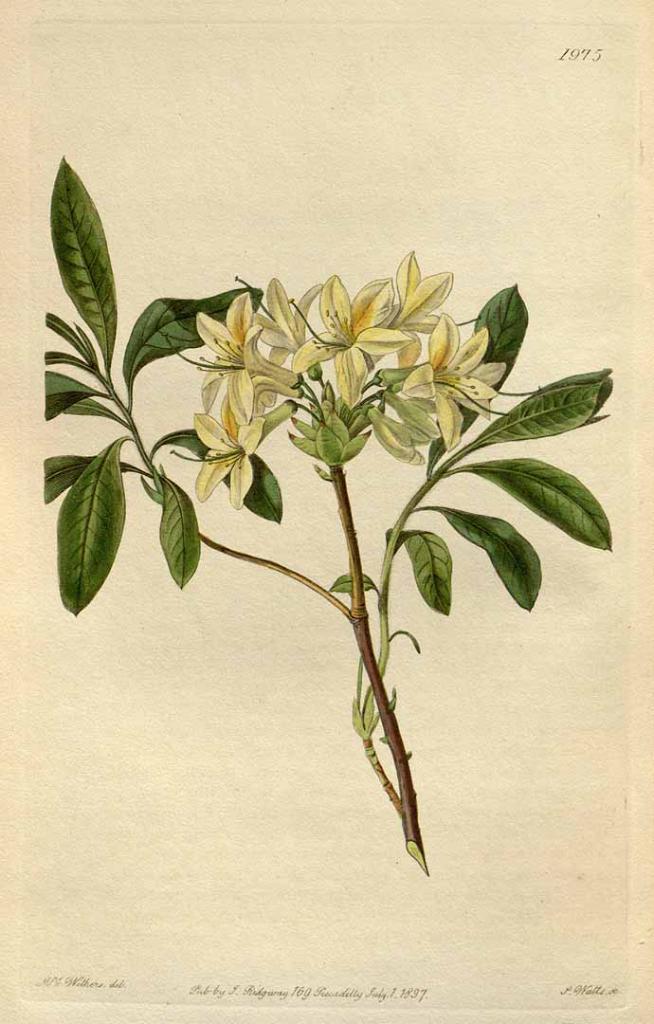Please provide a concise description of this image. In this image we can see the green leaves, stems and the flowers. At the top and bottom portion of the picture there is something written. 